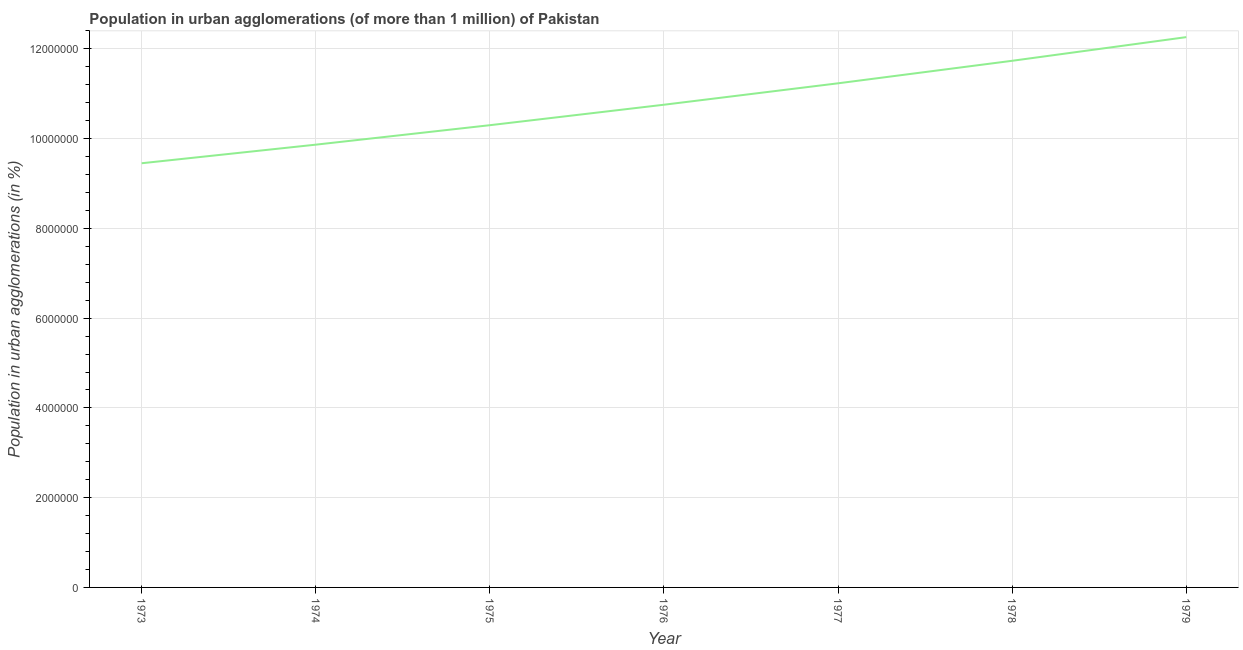What is the population in urban agglomerations in 1978?
Offer a terse response. 1.17e+07. Across all years, what is the maximum population in urban agglomerations?
Provide a short and direct response. 1.23e+07. Across all years, what is the minimum population in urban agglomerations?
Ensure brevity in your answer.  9.45e+06. In which year was the population in urban agglomerations maximum?
Provide a succinct answer. 1979. What is the sum of the population in urban agglomerations?
Give a very brief answer. 7.56e+07. What is the difference between the population in urban agglomerations in 1973 and 1978?
Keep it short and to the point. -2.28e+06. What is the average population in urban agglomerations per year?
Your answer should be compact. 1.08e+07. What is the median population in urban agglomerations?
Give a very brief answer. 1.08e+07. In how many years, is the population in urban agglomerations greater than 400000 %?
Give a very brief answer. 7. What is the ratio of the population in urban agglomerations in 1973 to that in 1976?
Provide a short and direct response. 0.88. Is the difference between the population in urban agglomerations in 1975 and 1976 greater than the difference between any two years?
Ensure brevity in your answer.  No. What is the difference between the highest and the second highest population in urban agglomerations?
Give a very brief answer. 5.27e+05. What is the difference between the highest and the lowest population in urban agglomerations?
Keep it short and to the point. 2.81e+06. In how many years, is the population in urban agglomerations greater than the average population in urban agglomerations taken over all years?
Ensure brevity in your answer.  3. Does the population in urban agglomerations monotonically increase over the years?
Offer a terse response. Yes. How many lines are there?
Make the answer very short. 1. Does the graph contain grids?
Make the answer very short. Yes. What is the title of the graph?
Your answer should be very brief. Population in urban agglomerations (of more than 1 million) of Pakistan. What is the label or title of the X-axis?
Offer a terse response. Year. What is the label or title of the Y-axis?
Your answer should be compact. Population in urban agglomerations (in %). What is the Population in urban agglomerations (in %) of 1973?
Ensure brevity in your answer.  9.45e+06. What is the Population in urban agglomerations (in %) of 1974?
Offer a very short reply. 9.87e+06. What is the Population in urban agglomerations (in %) in 1975?
Give a very brief answer. 1.03e+07. What is the Population in urban agglomerations (in %) in 1976?
Provide a short and direct response. 1.08e+07. What is the Population in urban agglomerations (in %) of 1977?
Give a very brief answer. 1.12e+07. What is the Population in urban agglomerations (in %) in 1978?
Your answer should be compact. 1.17e+07. What is the Population in urban agglomerations (in %) of 1979?
Provide a short and direct response. 1.23e+07. What is the difference between the Population in urban agglomerations (in %) in 1973 and 1974?
Offer a terse response. -4.14e+05. What is the difference between the Population in urban agglomerations (in %) in 1973 and 1975?
Provide a short and direct response. -8.48e+05. What is the difference between the Population in urban agglomerations (in %) in 1973 and 1976?
Offer a very short reply. -1.30e+06. What is the difference between the Population in urban agglomerations (in %) in 1973 and 1977?
Provide a short and direct response. -1.78e+06. What is the difference between the Population in urban agglomerations (in %) in 1973 and 1978?
Your response must be concise. -2.28e+06. What is the difference between the Population in urban agglomerations (in %) in 1973 and 1979?
Your answer should be very brief. -2.81e+06. What is the difference between the Population in urban agglomerations (in %) in 1974 and 1975?
Ensure brevity in your answer.  -4.34e+05. What is the difference between the Population in urban agglomerations (in %) in 1974 and 1976?
Your response must be concise. -8.90e+05. What is the difference between the Population in urban agglomerations (in %) in 1974 and 1977?
Your answer should be compact. -1.37e+06. What is the difference between the Population in urban agglomerations (in %) in 1974 and 1978?
Offer a very short reply. -1.87e+06. What is the difference between the Population in urban agglomerations (in %) in 1974 and 1979?
Offer a very short reply. -2.40e+06. What is the difference between the Population in urban agglomerations (in %) in 1975 and 1976?
Ensure brevity in your answer.  -4.56e+05. What is the difference between the Population in urban agglomerations (in %) in 1975 and 1977?
Offer a very short reply. -9.33e+05. What is the difference between the Population in urban agglomerations (in %) in 1975 and 1978?
Provide a short and direct response. -1.44e+06. What is the difference between the Population in urban agglomerations (in %) in 1975 and 1979?
Make the answer very short. -1.96e+06. What is the difference between the Population in urban agglomerations (in %) in 1976 and 1977?
Offer a very short reply. -4.77e+05. What is the difference between the Population in urban agglomerations (in %) in 1976 and 1978?
Provide a short and direct response. -9.79e+05. What is the difference between the Population in urban agglomerations (in %) in 1976 and 1979?
Provide a succinct answer. -1.51e+06. What is the difference between the Population in urban agglomerations (in %) in 1977 and 1978?
Offer a terse response. -5.02e+05. What is the difference between the Population in urban agglomerations (in %) in 1977 and 1979?
Offer a very short reply. -1.03e+06. What is the difference between the Population in urban agglomerations (in %) in 1978 and 1979?
Your response must be concise. -5.27e+05. What is the ratio of the Population in urban agglomerations (in %) in 1973 to that in 1974?
Provide a short and direct response. 0.96. What is the ratio of the Population in urban agglomerations (in %) in 1973 to that in 1975?
Ensure brevity in your answer.  0.92. What is the ratio of the Population in urban agglomerations (in %) in 1973 to that in 1976?
Ensure brevity in your answer.  0.88. What is the ratio of the Population in urban agglomerations (in %) in 1973 to that in 1977?
Make the answer very short. 0.84. What is the ratio of the Population in urban agglomerations (in %) in 1973 to that in 1978?
Your answer should be compact. 0.81. What is the ratio of the Population in urban agglomerations (in %) in 1973 to that in 1979?
Make the answer very short. 0.77. What is the ratio of the Population in urban agglomerations (in %) in 1974 to that in 1975?
Give a very brief answer. 0.96. What is the ratio of the Population in urban agglomerations (in %) in 1974 to that in 1976?
Provide a succinct answer. 0.92. What is the ratio of the Population in urban agglomerations (in %) in 1974 to that in 1977?
Make the answer very short. 0.88. What is the ratio of the Population in urban agglomerations (in %) in 1974 to that in 1978?
Ensure brevity in your answer.  0.84. What is the ratio of the Population in urban agglomerations (in %) in 1974 to that in 1979?
Provide a short and direct response. 0.81. What is the ratio of the Population in urban agglomerations (in %) in 1975 to that in 1976?
Offer a terse response. 0.96. What is the ratio of the Population in urban agglomerations (in %) in 1975 to that in 1977?
Ensure brevity in your answer.  0.92. What is the ratio of the Population in urban agglomerations (in %) in 1975 to that in 1978?
Ensure brevity in your answer.  0.88. What is the ratio of the Population in urban agglomerations (in %) in 1975 to that in 1979?
Offer a terse response. 0.84. What is the ratio of the Population in urban agglomerations (in %) in 1976 to that in 1977?
Make the answer very short. 0.96. What is the ratio of the Population in urban agglomerations (in %) in 1976 to that in 1978?
Your response must be concise. 0.92. What is the ratio of the Population in urban agglomerations (in %) in 1976 to that in 1979?
Ensure brevity in your answer.  0.88. What is the ratio of the Population in urban agglomerations (in %) in 1977 to that in 1978?
Offer a terse response. 0.96. What is the ratio of the Population in urban agglomerations (in %) in 1977 to that in 1979?
Your response must be concise. 0.92. What is the ratio of the Population in urban agglomerations (in %) in 1978 to that in 1979?
Ensure brevity in your answer.  0.96. 